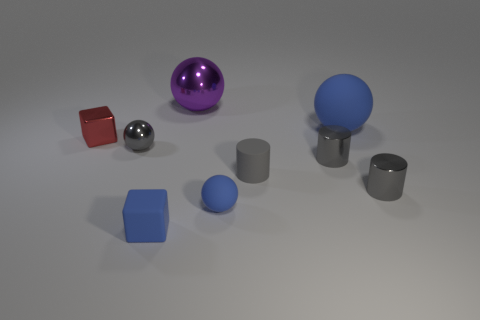Subtract all rubber cylinders. How many cylinders are left? 2 Subtract all yellow blocks. How many blue spheres are left? 2 Add 1 matte cubes. How many objects exist? 10 Subtract all gray balls. How many balls are left? 3 Subtract all cylinders. How many objects are left? 6 Subtract 2 cylinders. How many cylinders are left? 1 Subtract all brown cylinders. Subtract all blue spheres. How many cylinders are left? 3 Subtract all large blue rubber objects. Subtract all small cubes. How many objects are left? 6 Add 1 gray cylinders. How many gray cylinders are left? 4 Add 2 purple metallic spheres. How many purple metallic spheres exist? 3 